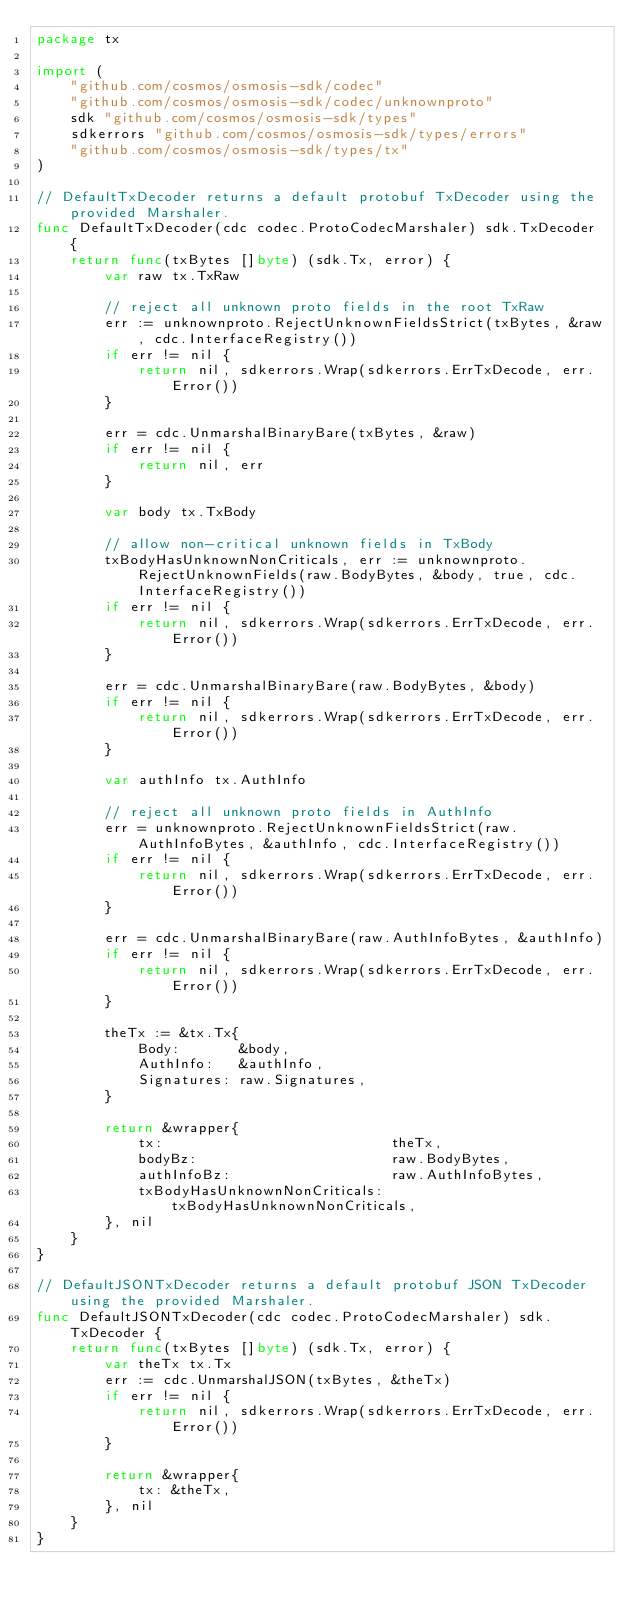<code> <loc_0><loc_0><loc_500><loc_500><_Go_>package tx

import (
	"github.com/cosmos/osmosis-sdk/codec"
	"github.com/cosmos/osmosis-sdk/codec/unknownproto"
	sdk "github.com/cosmos/osmosis-sdk/types"
	sdkerrors "github.com/cosmos/osmosis-sdk/types/errors"
	"github.com/cosmos/osmosis-sdk/types/tx"
)

// DefaultTxDecoder returns a default protobuf TxDecoder using the provided Marshaler.
func DefaultTxDecoder(cdc codec.ProtoCodecMarshaler) sdk.TxDecoder {
	return func(txBytes []byte) (sdk.Tx, error) {
		var raw tx.TxRaw

		// reject all unknown proto fields in the root TxRaw
		err := unknownproto.RejectUnknownFieldsStrict(txBytes, &raw, cdc.InterfaceRegistry())
		if err != nil {
			return nil, sdkerrors.Wrap(sdkerrors.ErrTxDecode, err.Error())
		}

		err = cdc.UnmarshalBinaryBare(txBytes, &raw)
		if err != nil {
			return nil, err
		}

		var body tx.TxBody

		// allow non-critical unknown fields in TxBody
		txBodyHasUnknownNonCriticals, err := unknownproto.RejectUnknownFields(raw.BodyBytes, &body, true, cdc.InterfaceRegistry())
		if err != nil {
			return nil, sdkerrors.Wrap(sdkerrors.ErrTxDecode, err.Error())
		}

		err = cdc.UnmarshalBinaryBare(raw.BodyBytes, &body)
		if err != nil {
			return nil, sdkerrors.Wrap(sdkerrors.ErrTxDecode, err.Error())
		}

		var authInfo tx.AuthInfo

		// reject all unknown proto fields in AuthInfo
		err = unknownproto.RejectUnknownFieldsStrict(raw.AuthInfoBytes, &authInfo, cdc.InterfaceRegistry())
		if err != nil {
			return nil, sdkerrors.Wrap(sdkerrors.ErrTxDecode, err.Error())
		}

		err = cdc.UnmarshalBinaryBare(raw.AuthInfoBytes, &authInfo)
		if err != nil {
			return nil, sdkerrors.Wrap(sdkerrors.ErrTxDecode, err.Error())
		}

		theTx := &tx.Tx{
			Body:       &body,
			AuthInfo:   &authInfo,
			Signatures: raw.Signatures,
		}

		return &wrapper{
			tx:                           theTx,
			bodyBz:                       raw.BodyBytes,
			authInfoBz:                   raw.AuthInfoBytes,
			txBodyHasUnknownNonCriticals: txBodyHasUnknownNonCriticals,
		}, nil
	}
}

// DefaultJSONTxDecoder returns a default protobuf JSON TxDecoder using the provided Marshaler.
func DefaultJSONTxDecoder(cdc codec.ProtoCodecMarshaler) sdk.TxDecoder {
	return func(txBytes []byte) (sdk.Tx, error) {
		var theTx tx.Tx
		err := cdc.UnmarshalJSON(txBytes, &theTx)
		if err != nil {
			return nil, sdkerrors.Wrap(sdkerrors.ErrTxDecode, err.Error())
		}

		return &wrapper{
			tx: &theTx,
		}, nil
	}
}
</code> 